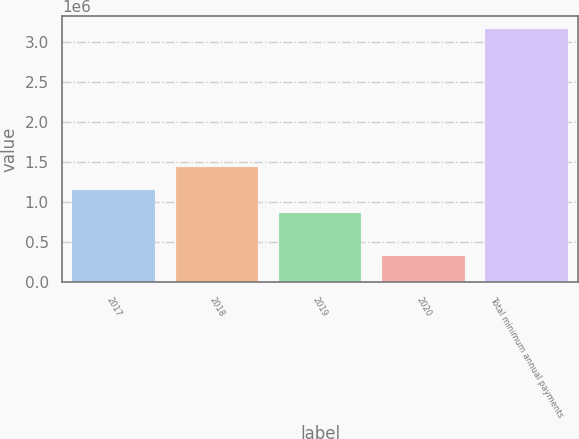Convert chart to OTSL. <chart><loc_0><loc_0><loc_500><loc_500><bar_chart><fcel>2017<fcel>2018<fcel>2019<fcel>2020<fcel>Total minimum annual payments<nl><fcel>1.15247e+06<fcel>1.4352e+06<fcel>869745<fcel>326711<fcel>3.154e+06<nl></chart> 